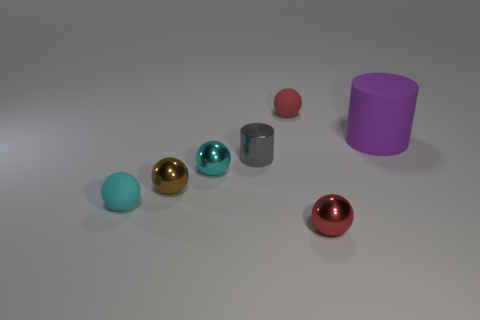Subtract 2 spheres. How many spheres are left? 3 Subtract all brown balls. How many balls are left? 4 Subtract all tiny cyan metallic spheres. How many spheres are left? 4 Subtract all blue spheres. Subtract all cyan cylinders. How many spheres are left? 5 Add 2 brown balls. How many objects exist? 9 Subtract all spheres. How many objects are left? 2 Add 2 small cyan shiny things. How many small cyan shiny things are left? 3 Add 4 small red shiny objects. How many small red shiny objects exist? 5 Subtract 0 yellow spheres. How many objects are left? 7 Subtract all big blue shiny blocks. Subtract all big purple rubber cylinders. How many objects are left? 6 